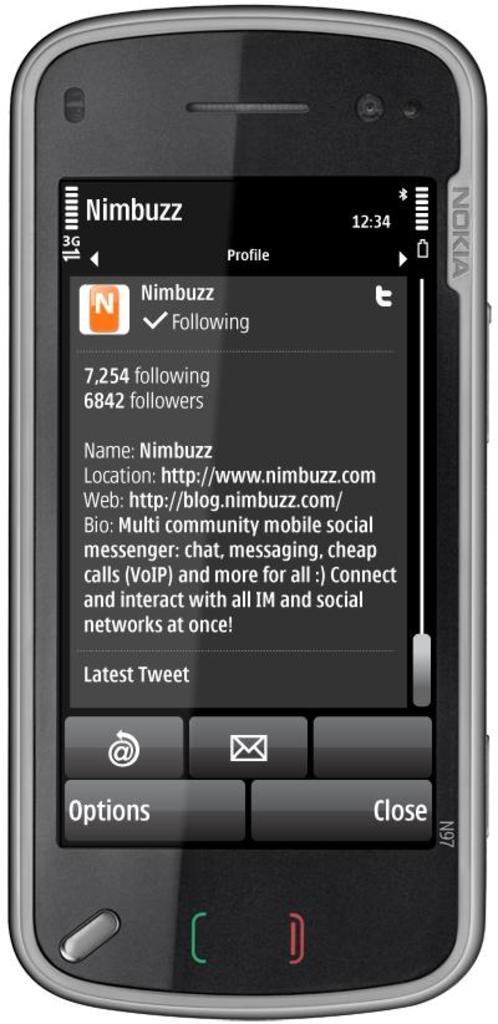Provide a one-sentence caption for the provided image. an Nimbuzz app on a Nokia phone. 